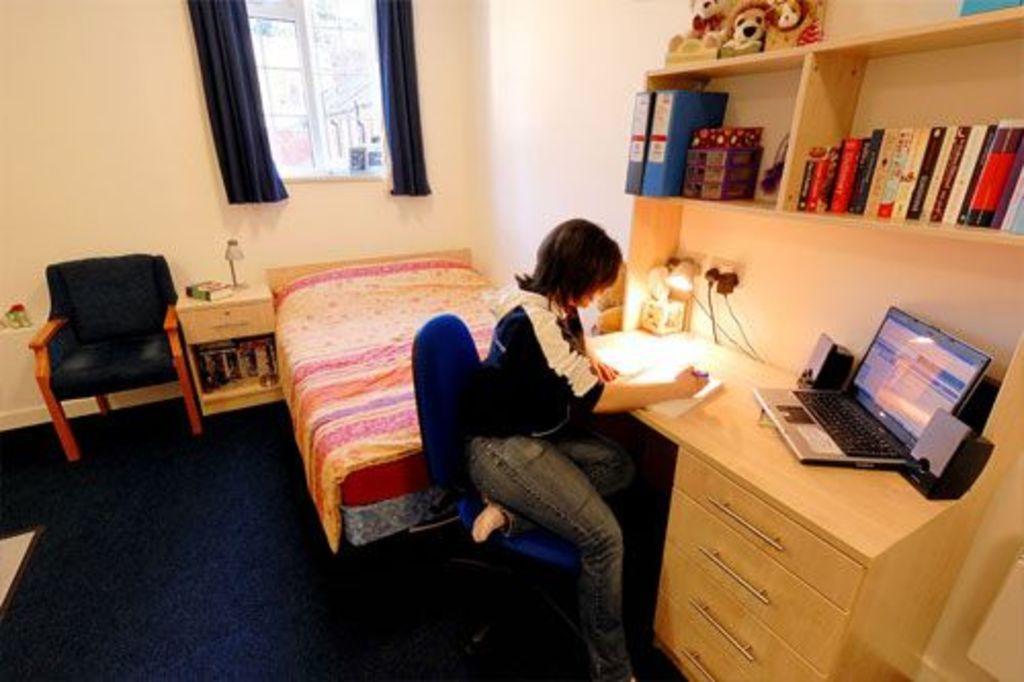In one or two sentences, can you explain what this image depicts? In this picture there is a woman sitting in the chair in front of a table on which some laptops, books and a lamp is placed. Above her there is a bookshelf in which some books were placed. In the background there is a bed, chair and curtains to the windows. 